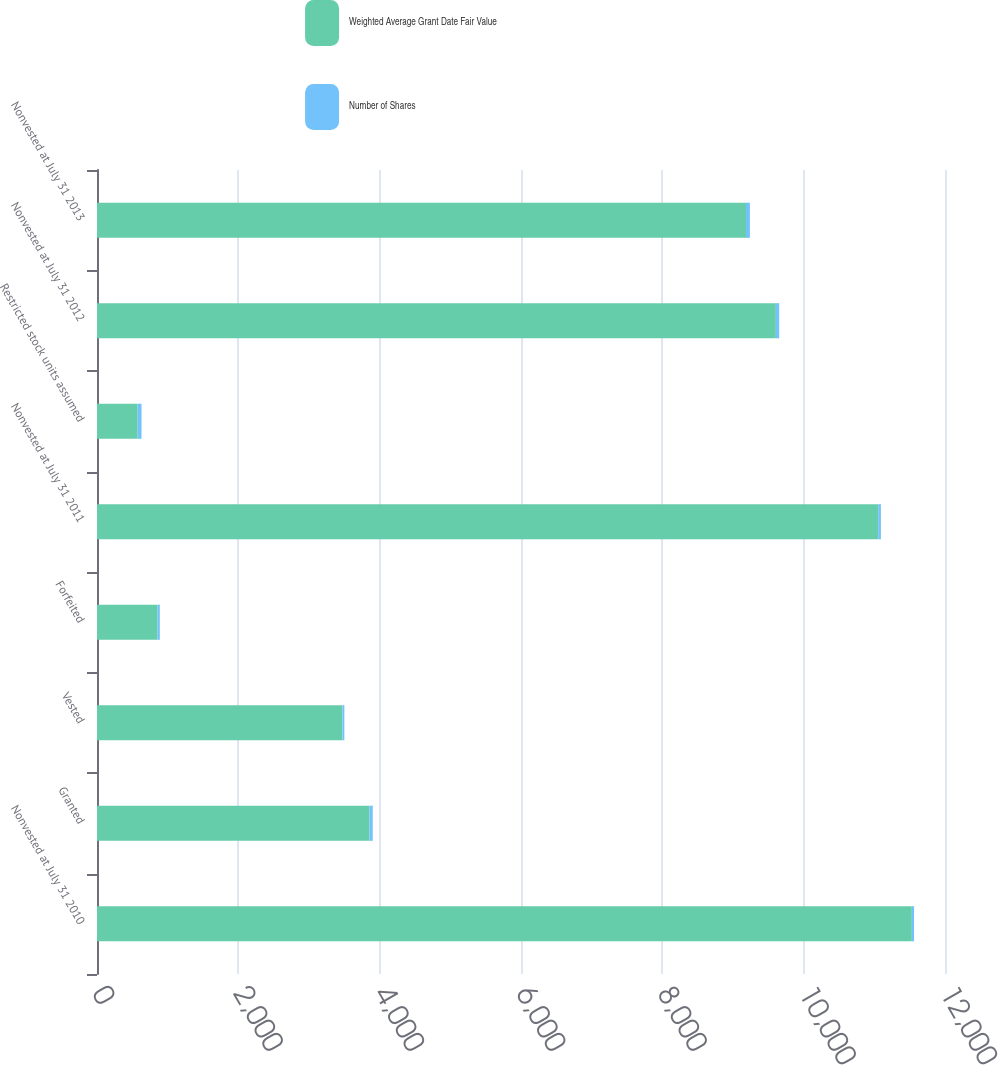Convert chart to OTSL. <chart><loc_0><loc_0><loc_500><loc_500><stacked_bar_chart><ecel><fcel>Nonvested at July 31 2010<fcel>Granted<fcel>Vested<fcel>Forfeited<fcel>Nonvested at July 31 2011<fcel>Restricted stock units assumed<fcel>Nonvested at July 31 2012<fcel>Nonvested at July 31 2013<nl><fcel>Weighted Average Grant Date Fair Value<fcel>11531<fcel>3855<fcel>3474<fcel>857<fcel>11055<fcel>575<fcel>9607<fcel>9184<nl><fcel>Number of Shares<fcel>30.93<fcel>47.02<fcel>26.33<fcel>31.73<fcel>37.92<fcel>54.51<fcel>46.79<fcel>55.23<nl></chart> 